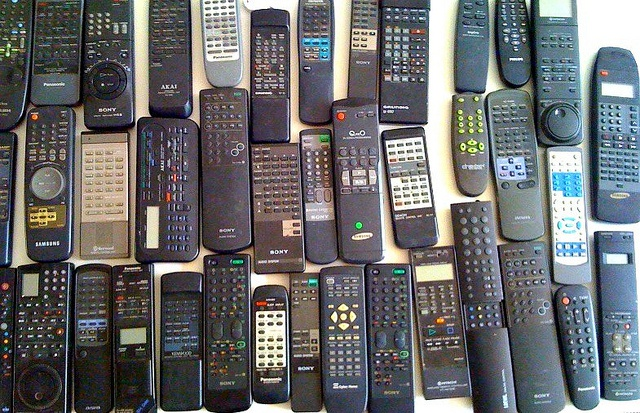Describe the objects in this image and their specific colors. I can see remote in navy, gray, and white tones, remote in navy, black, gray, ivory, and darkgray tones, remote in navy, gray, black, and purple tones, remote in navy and gray tones, and remote in navy, gray, darkgray, and black tones in this image. 